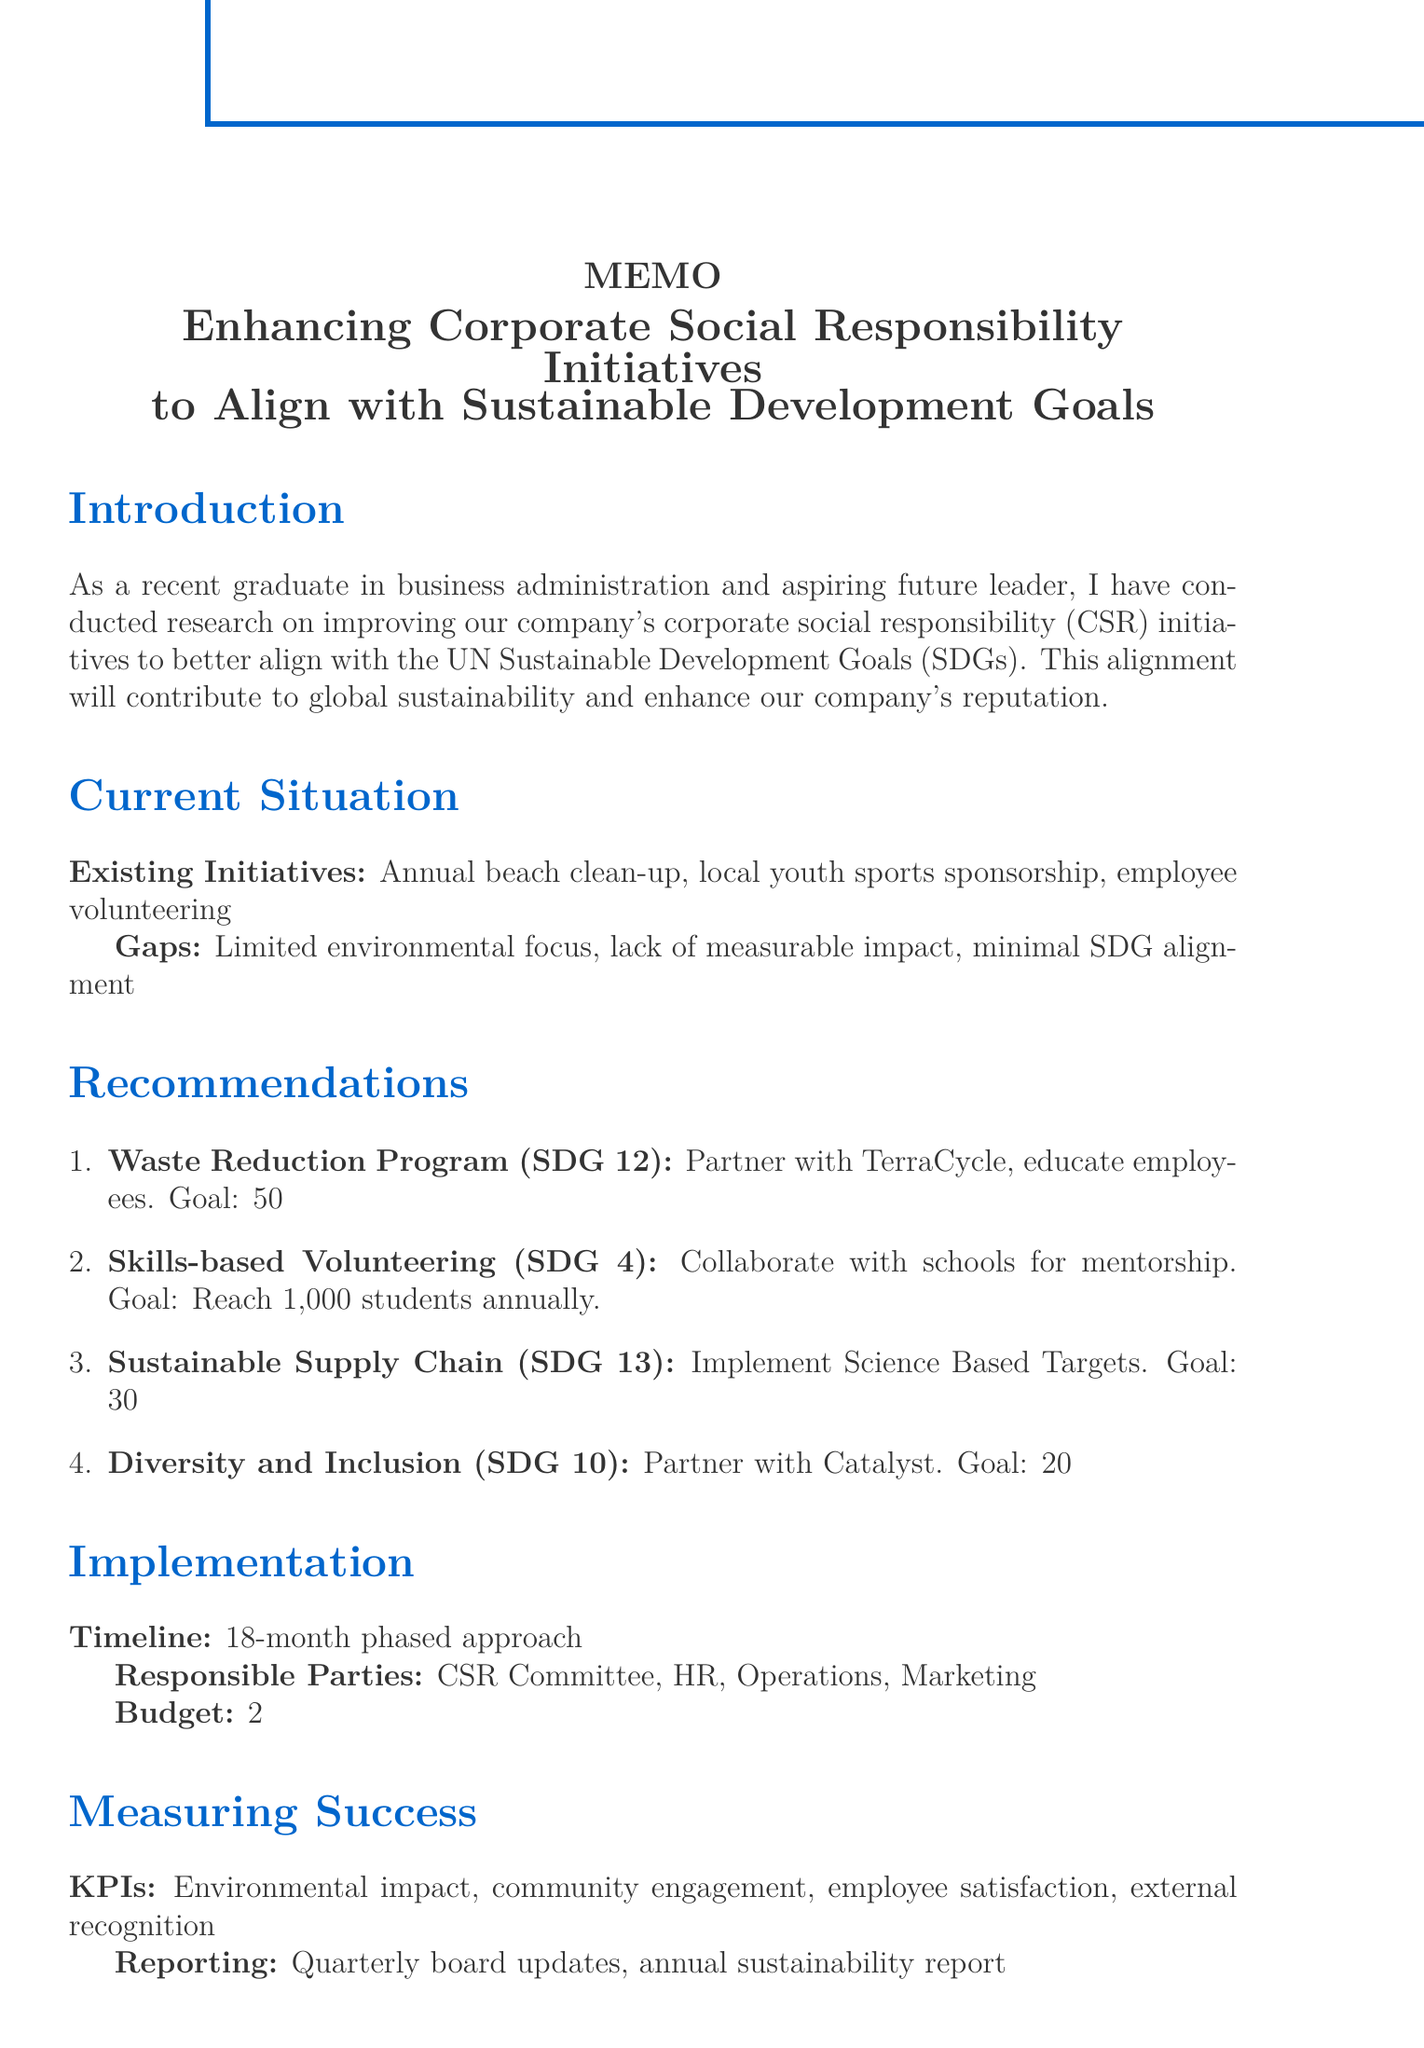What is the title of the memo? The title of the memo is explicitly stated at the beginning of the document, which outlines its purpose.
Answer: Enhancing Corporate Social Responsibility Initiatives to Align with Sustainable Development Goals How many existing initiatives are listed? The document explicitly lists the existing CSR initiatives under the "Current Situation" section.
Answer: 3 Which SDG is related to the waste reduction program? The related SDG for the waste reduction program is specified alongside the initiative in the recommendations section.
Answer: SDG 12: Responsible Consumption and Production What is the implementation timeline for the recommendations? The timeline for implementing the recommendations is outlined in the "Implementation" section of the memo.
Answer: Phased approach over 18 months What is the expected outcome of the sustainable supply chain strategy? The expected outcome is detailed in the recommendations section and provides a clear target.
Answer: Achieve a 30% reduction in supply chain emissions by 2025 Who is responsible for overseeing the initiatives? The responsible parties are enumerated in the "Implementation" section, detailing who will be involved in the process.
Answer: CSR Committee, Human Resources, Operations, Marketing What is the budget consideration for the CSR initiatives? The budget allocation is mentioned under the "Implementation" section and indicates the financial commitment to the CSR initiatives.
Answer: Allocate 2% of annual profits to CSR initiatives How often will success be reported? The frequency of reporting is specified in the "Measuring Success" section, indicating how often updates will be provided.
Answer: Quarterly updates to the board and annual sustainability report 